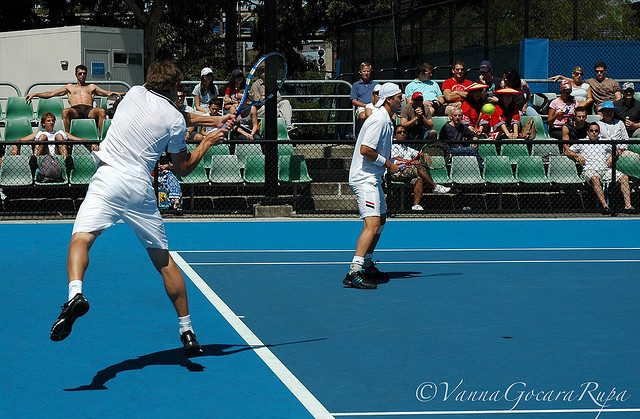<image>Which player just got a point? It is ambiguous which player just got a point. It can be the one on left or right. Which player just got a point? I don't know which player just got a point. It could be the one on the left, the guy without a hat, the player on the right, or the jumping one. 